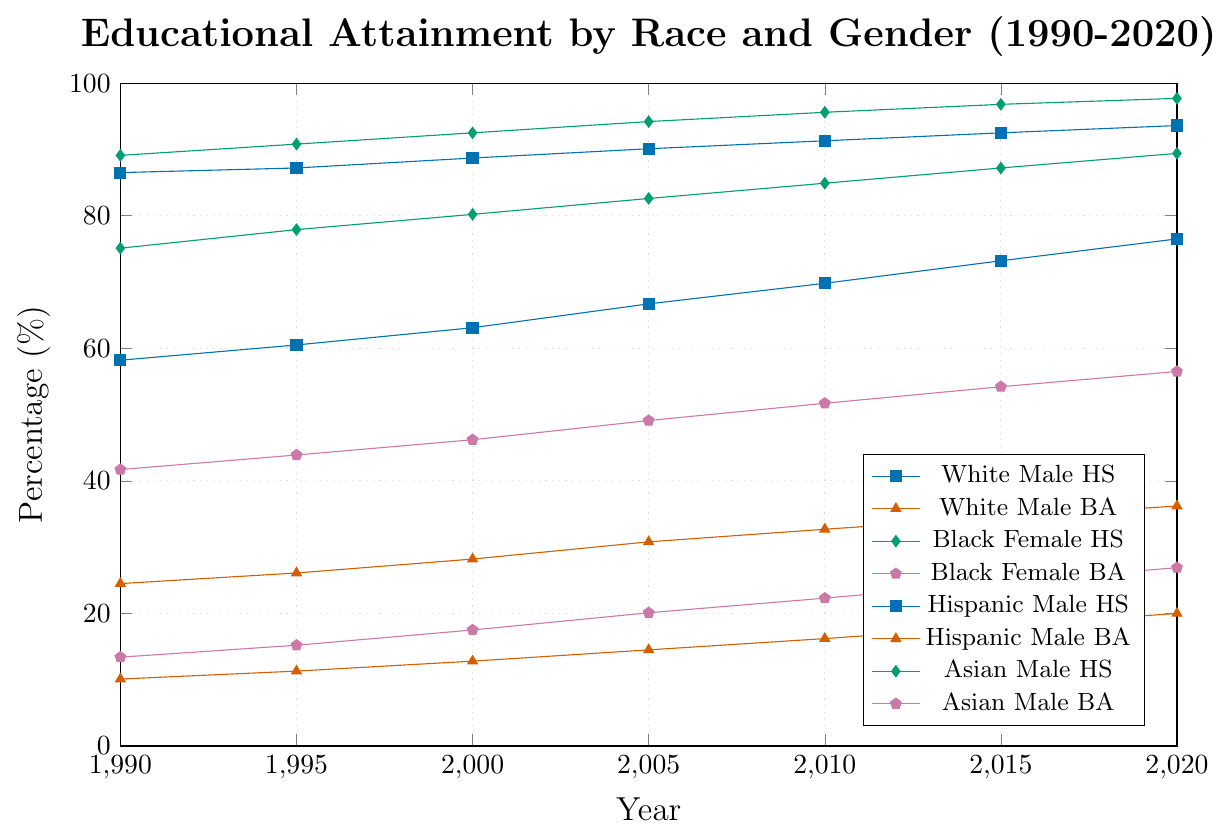What is the percentage of White Males with a Bachelor's degree in 2020? Look for the point corresponding to 2020 on the line for White Males with a Bachelor's (BA) degree. Refer to the legends for color and marker style identification.
Answer: 36.2% How did the percentage of Black Females with a High School diploma change from 1990 to 2020? Identify the starting value in 1990 and the end value in 2020 for Black Females with a High School (HS) diploma by looking at the corresponding line in the plot. Subtract the 1990 value from the 2020 value.
Answer: Increased by 14.3% Which group had the highest percentage of individuals with a High School diploma in 2020? Compare the data points for the year 2020 for each group with a High School diploma by looking at the highest points on the lines corresponding to 2020.
Answer: Asian Males What is the difference in the percentage of Bachelor's degree attainment between Hispanic Males and Hispanic Females in 2000? Find the Bachelor's degree data points for both Hispanic Males and Hispanic Females in 2000, and subtract the Hispanic Female percentage from the Hispanic Male percentage.
Answer: 0.1% Between 1990 and 2020, which group showed the most significant increase in Bachelor's degree attainment percentage? Calculate the difference between 2020 and 1990 for the Bachelor's degree attainment for each group, then identify the highest value.
Answer: Asian Males Which group had a higher percentage: Black Females with a Bachelor's degree or Hispanic Males with a High School diploma in 2005? Compare the 2005 values of Black Females with a Bachelor's degree and Hispanic Males with a High School diploma from the plot.
Answer: Hispanic Males with a High School diploma How did the percentage of Asian Males with a High School diploma evolve from 1990 to 2020? Identify the starting value in 1990 and the end value in 2020 for Asian Males with a High School diploma. Describe the general trend observed in the plot.
Answer: Increased from 89.1% to 97.7% What is the average percentage of White Females with a Graduate degree in 1990 and 2020? Locate the percentage values for White Females with a Graduate degree in both 1990 and 2020. Calculate the average by summing them up and dividing by 2.
Answer: 9.6% Which group exhibited the smallest percentage increase in Bachelor's degree attainment from 1990 to 2020? Calculate the percentage difference in Bachelor's degree attainment for each group between 1990 and 2020, and identify the group with the smallest increase.
Answer: Hispanic Males 